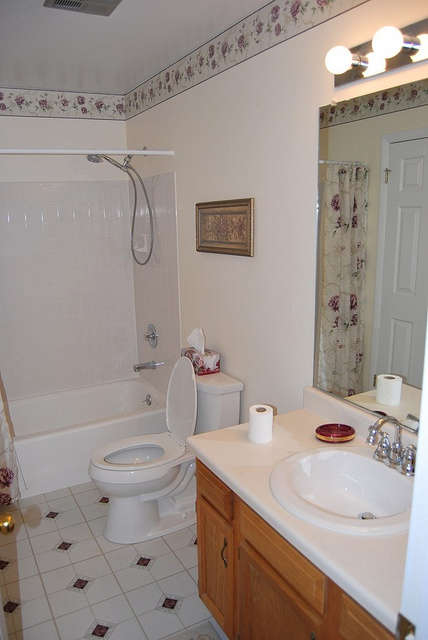Describe the objects in this image and their specific colors. I can see toilet in gray and darkgray tones, sink in gray, lightgray, and darkgray tones, and bowl in gray, maroon, brown, and darkgray tones in this image. 